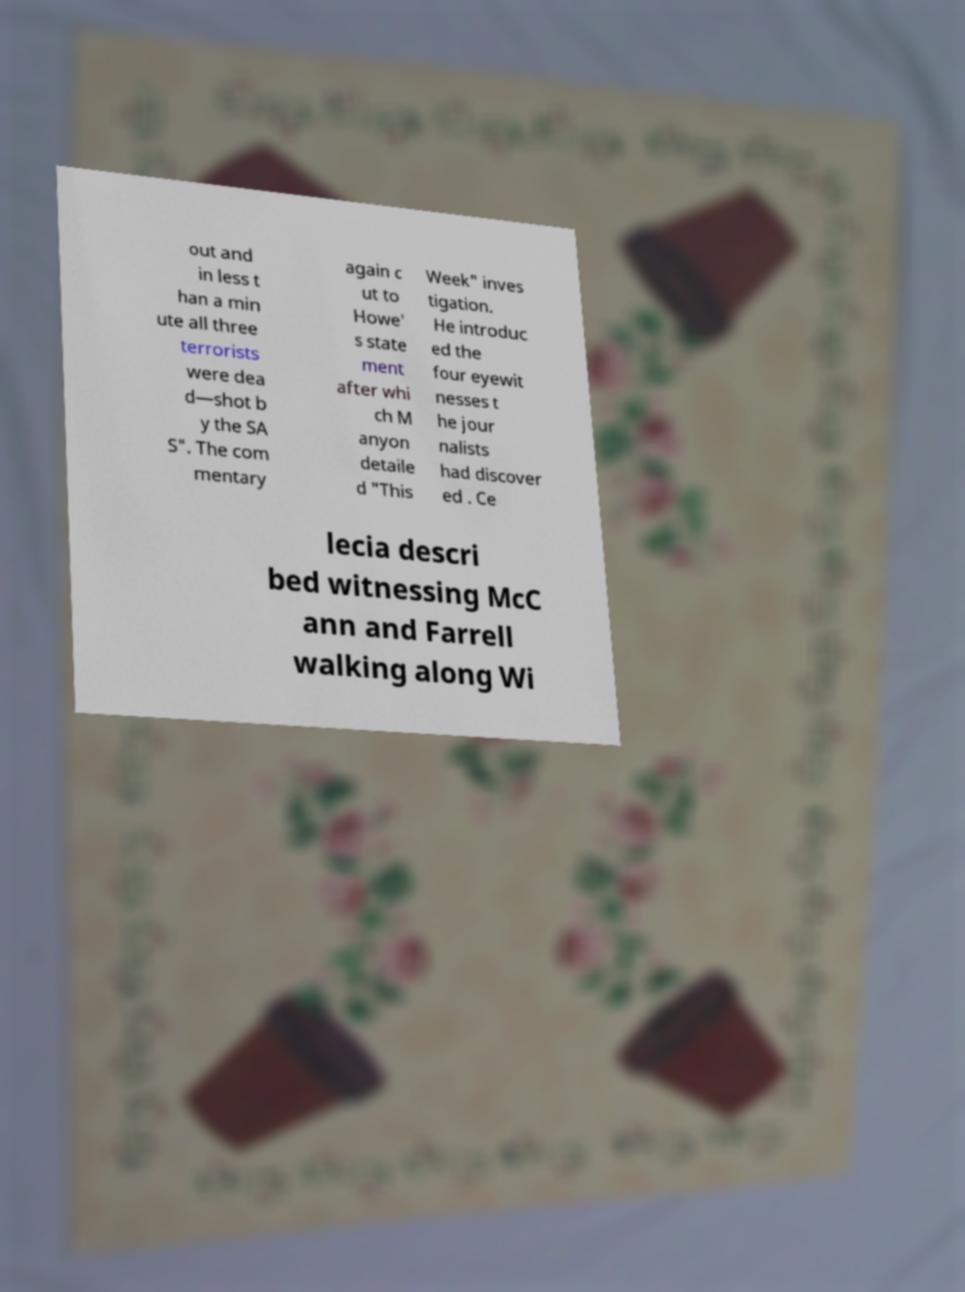Can you accurately transcribe the text from the provided image for me? out and in less t han a min ute all three terrorists were dea d—shot b y the SA S". The com mentary again c ut to Howe' s state ment after whi ch M anyon detaile d "This Week" inves tigation. He introduc ed the four eyewit nesses t he jour nalists had discover ed . Ce lecia descri bed witnessing McC ann and Farrell walking along Wi 